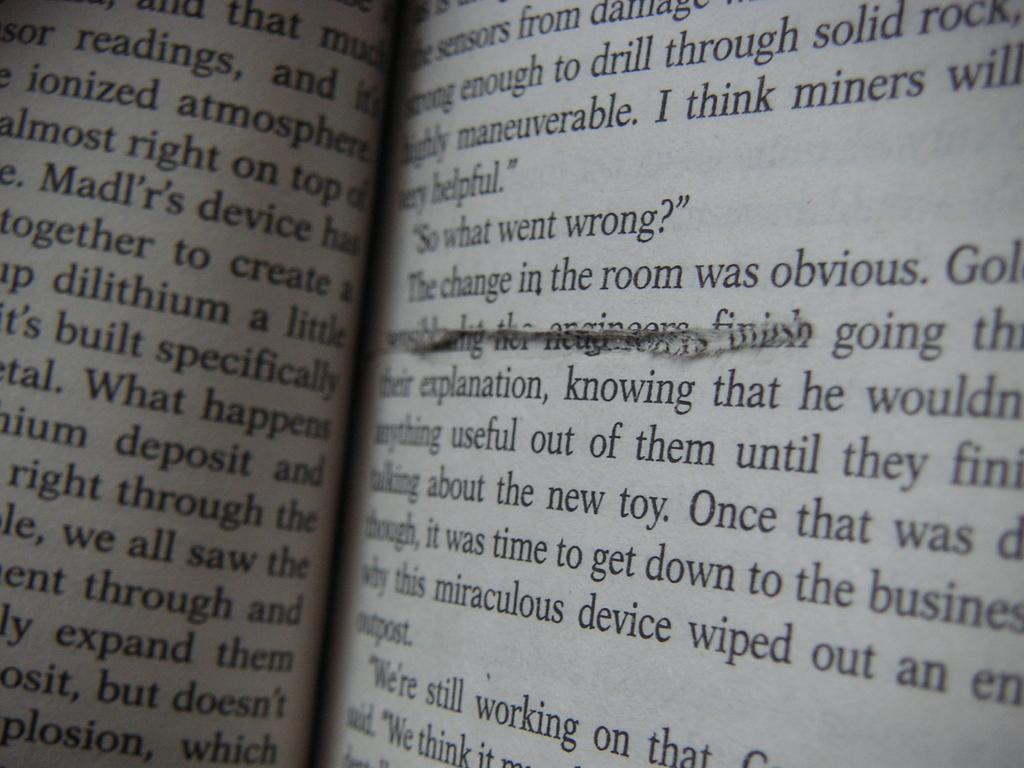<image>
Create a compact narrative representing the image presented. A book is open and words are partially visible on both pages, dialog reading "So what went wrong?" is centered on the right page. 